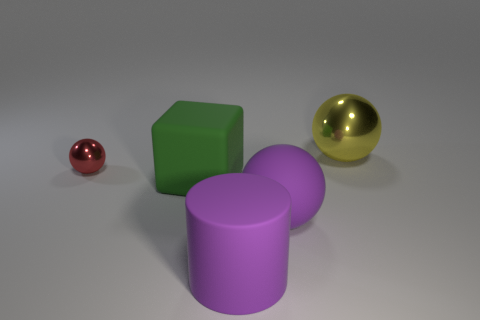Subtract all large spheres. How many spheres are left? 1 Add 3 purple matte things. How many objects exist? 8 Subtract all balls. How many objects are left? 2 Subtract all cyan spheres. Subtract all brown blocks. How many spheres are left? 3 Add 4 big objects. How many big objects are left? 8 Add 2 blocks. How many blocks exist? 3 Subtract 0 red cylinders. How many objects are left? 5 Subtract all blocks. Subtract all green spheres. How many objects are left? 4 